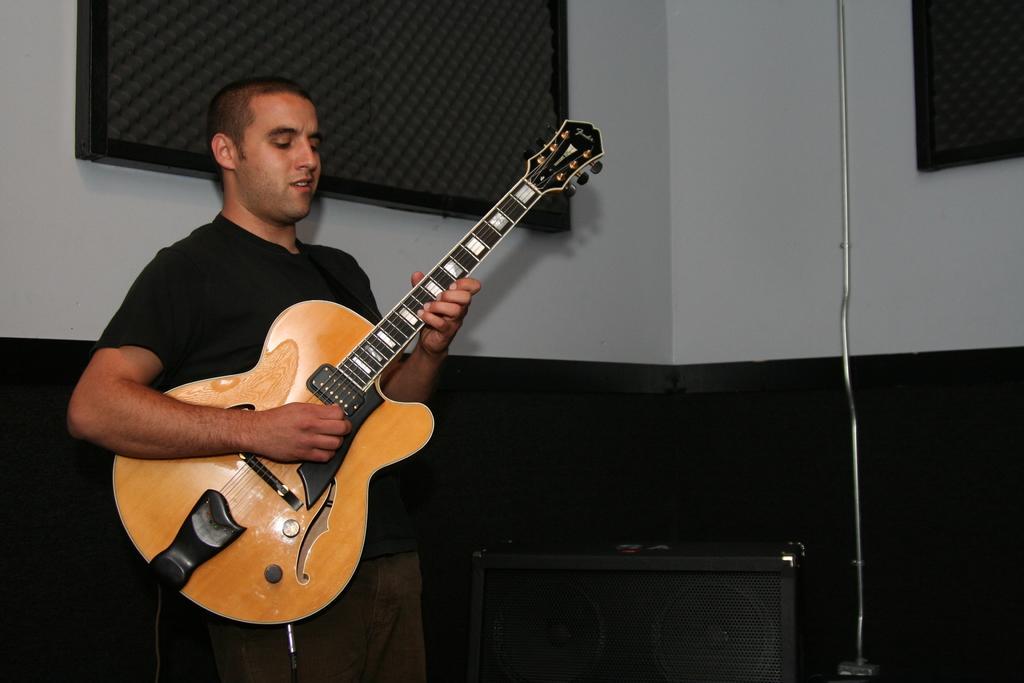Describe this image in one or two sentences. In this image there is a man standing. He is holding and playing a guitar in his hand. There is a speaker beside him. In the background there is wall. 